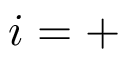<formula> <loc_0><loc_0><loc_500><loc_500>i = +</formula> 